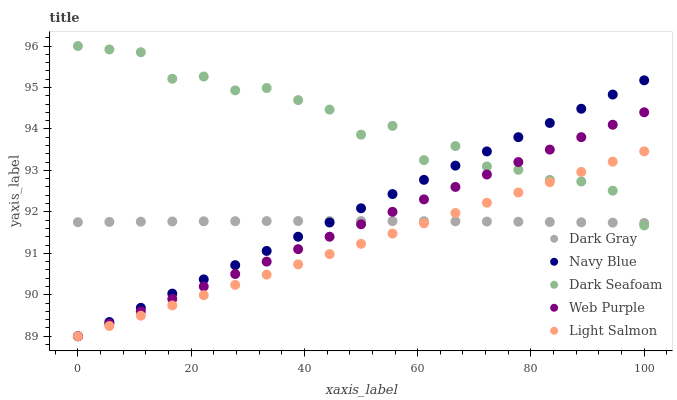Does Light Salmon have the minimum area under the curve?
Answer yes or no. Yes. Does Dark Seafoam have the maximum area under the curve?
Answer yes or no. Yes. Does Navy Blue have the minimum area under the curve?
Answer yes or no. No. Does Navy Blue have the maximum area under the curve?
Answer yes or no. No. Is Light Salmon the smoothest?
Answer yes or no. Yes. Is Dark Seafoam the roughest?
Answer yes or no. Yes. Is Navy Blue the smoothest?
Answer yes or no. No. Is Navy Blue the roughest?
Answer yes or no. No. Does Navy Blue have the lowest value?
Answer yes or no. Yes. Does Dark Seafoam have the lowest value?
Answer yes or no. No. Does Dark Seafoam have the highest value?
Answer yes or no. Yes. Does Navy Blue have the highest value?
Answer yes or no. No. Does Dark Gray intersect Dark Seafoam?
Answer yes or no. Yes. Is Dark Gray less than Dark Seafoam?
Answer yes or no. No. Is Dark Gray greater than Dark Seafoam?
Answer yes or no. No. 